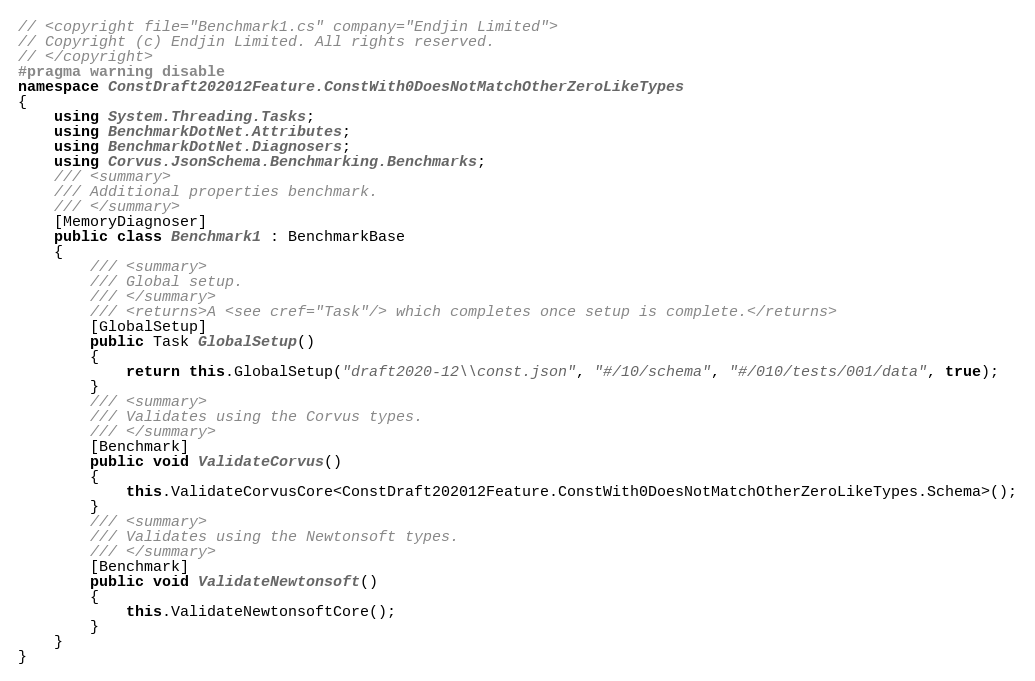Convert code to text. <code><loc_0><loc_0><loc_500><loc_500><_C#_>// <copyright file="Benchmark1.cs" company="Endjin Limited">
// Copyright (c) Endjin Limited. All rights reserved.
// </copyright>
#pragma warning disable
namespace ConstDraft202012Feature.ConstWith0DoesNotMatchOtherZeroLikeTypes
{
    using System.Threading.Tasks;
    using BenchmarkDotNet.Attributes;
    using BenchmarkDotNet.Diagnosers;
    using Corvus.JsonSchema.Benchmarking.Benchmarks;
    /// <summary>
    /// Additional properties benchmark.
    /// </summary>
    [MemoryDiagnoser]
    public class Benchmark1 : BenchmarkBase
    {
        /// <summary>
        /// Global setup.
        /// </summary>
        /// <returns>A <see cref="Task"/> which completes once setup is complete.</returns>
        [GlobalSetup]
        public Task GlobalSetup()
        {
            return this.GlobalSetup("draft2020-12\\const.json", "#/10/schema", "#/010/tests/001/data", true);
        }
        /// <summary>
        /// Validates using the Corvus types.
        /// </summary>
        [Benchmark]
        public void ValidateCorvus()
        {
            this.ValidateCorvusCore<ConstDraft202012Feature.ConstWith0DoesNotMatchOtherZeroLikeTypes.Schema>();
        }
        /// <summary>
        /// Validates using the Newtonsoft types.
        /// </summary>
        [Benchmark]
        public void ValidateNewtonsoft()
        {
            this.ValidateNewtonsoftCore();
        }
    }
}
</code> 